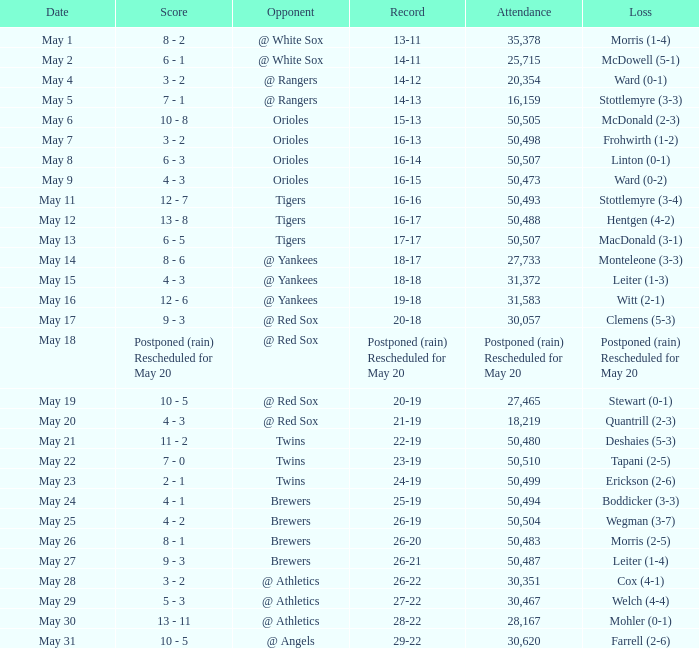What team did they lose to when they had a 28-22 record? Mohler (0-1). 